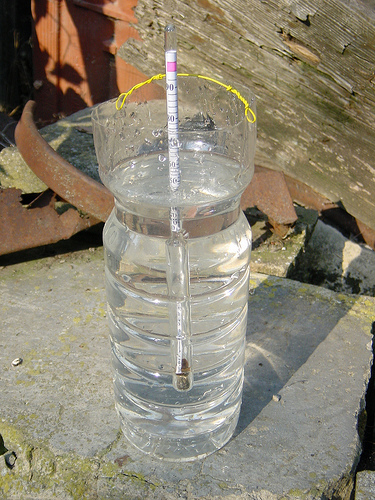<image>
Is there a wire on the wood? No. The wire is not positioned on the wood. They may be near each other, but the wire is not supported by or resting on top of the wood. Is the thermometer next to the bottle? No. The thermometer is not positioned next to the bottle. They are located in different areas of the scene. 